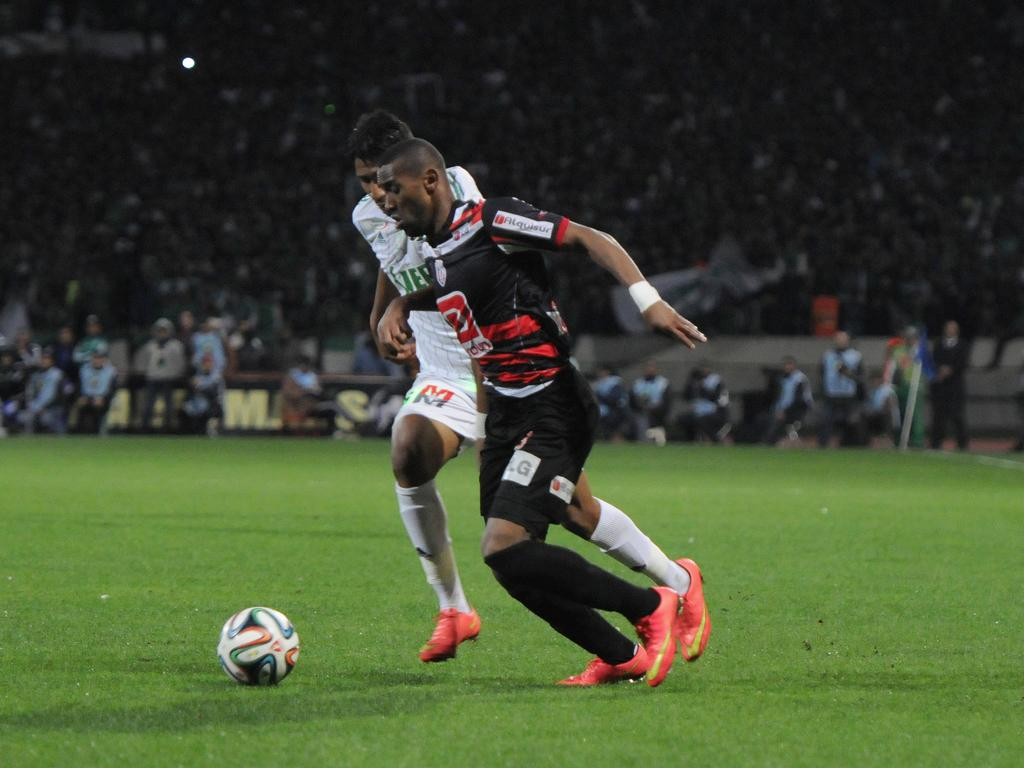What are the two people in the image doing? The two people in the image are running on the grassland. What are the people holding while running? The people are holding a ball. Can you describe the environment where the people are running? The people are running on a grassland, and there are other people present in the same area. What can be seen in the background of the image? There is a banner visible in the image. Where are some other people located in the image? There are people on the stairs at the top of the image. What type of headwear is the goldfish wearing in the image? There is no goldfish present in the image, and therefore no headwear can be observed. 